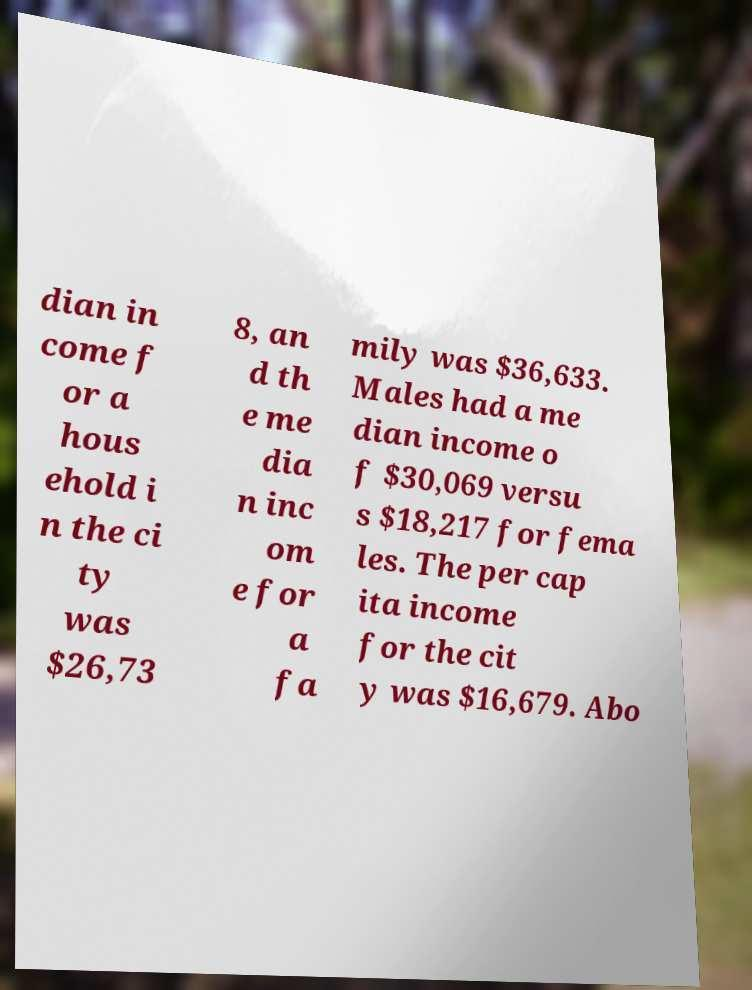For documentation purposes, I need the text within this image transcribed. Could you provide that? dian in come f or a hous ehold i n the ci ty was $26,73 8, an d th e me dia n inc om e for a fa mily was $36,633. Males had a me dian income o f $30,069 versu s $18,217 for fema les. The per cap ita income for the cit y was $16,679. Abo 